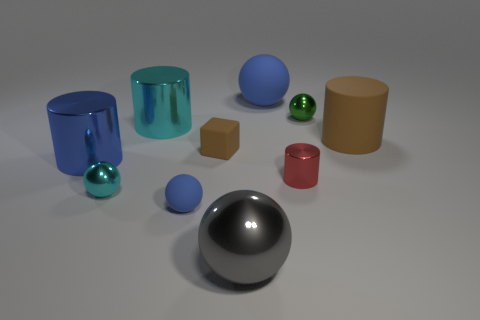How does the size of the shiny green sphere compare to the red one next to it? The shiny green sphere is larger in size compared to the smaller red sphere next to it. The green sphere's reflective surface creates highlights and shadows that emphasize its volume compared to the matte red sphere. Is there a light source depicted within the image, or are the shadows and highlights due to an external light source? There is no visible light source depicted within the image itself. The shadows and highlights on the objects suggest that the lighting is coming from an external source off-camera, likely positioned above the scene to create the observed effects. 